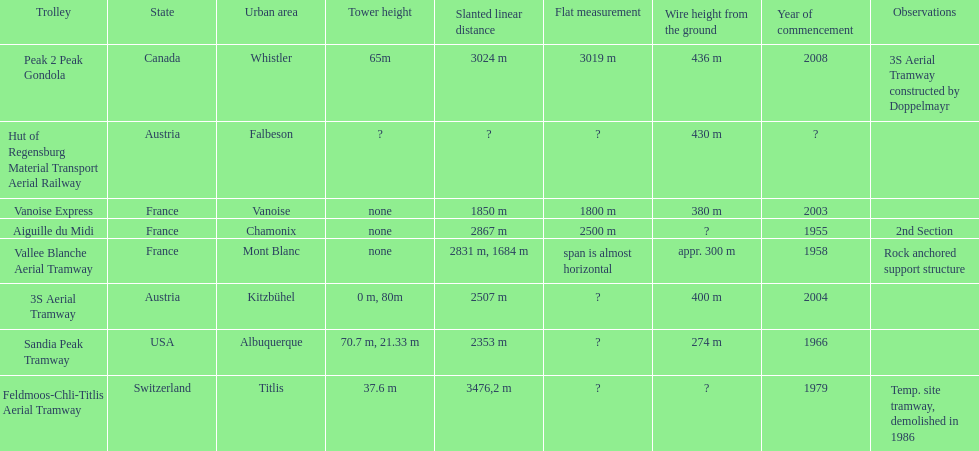Which tramway was built directly before the 3s aeriral tramway? Vanoise Express. 